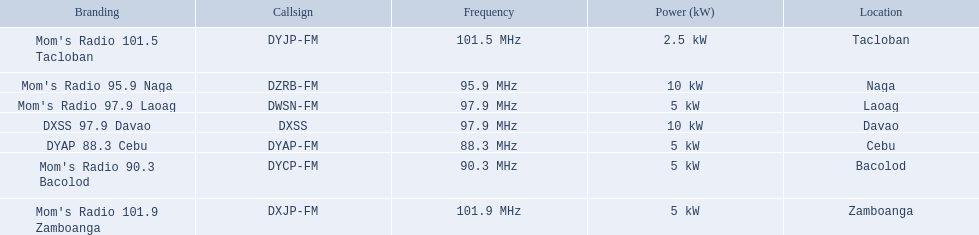What are all of the frequencies? 97.9 MHz, 95.9 MHz, 90.3 MHz, 88.3 MHz, 101.5 MHz, 101.9 MHz, 97.9 MHz. Which of these frequencies is the lowest? 88.3 MHz. Help me parse the entirety of this table. {'header': ['Branding', 'Callsign', 'Frequency', 'Power (kW)', 'Location'], 'rows': [["Mom's Radio 101.5 Tacloban", 'DYJP-FM', '101.5\xa0MHz', '2.5\xa0kW', 'Tacloban'], ["Mom's Radio 95.9 Naga", 'DZRB-FM', '95.9\xa0MHz', '10\xa0kW', 'Naga'], ["Mom's Radio 97.9 Laoag", 'DWSN-FM', '97.9\xa0MHz', '5\xa0kW', 'Laoag'], ['DXSS 97.9 Davao', 'DXSS', '97.9\xa0MHz', '10\xa0kW', 'Davao'], ['DYAP 88.3 Cebu', 'DYAP-FM', '88.3\xa0MHz', '5\xa0kW', 'Cebu'], ["Mom's Radio 90.3 Bacolod", 'DYCP-FM', '90.3\xa0MHz', '5\xa0kW', 'Bacolod'], ["Mom's Radio 101.9 Zamboanga", 'DXJP-FM', '101.9\xa0MHz', '5\xa0kW', 'Zamboanga']]} Which branding does this frequency belong to? DYAP 88.3 Cebu. 